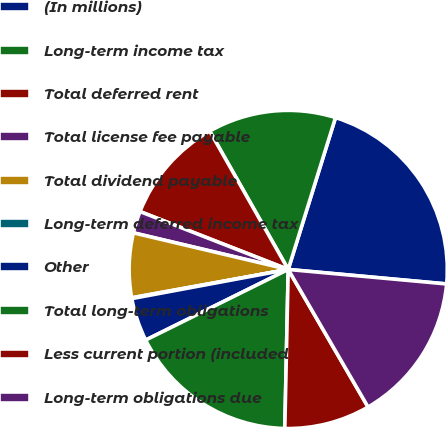Convert chart. <chart><loc_0><loc_0><loc_500><loc_500><pie_chart><fcel>(In millions)<fcel>Long-term income tax<fcel>Total deferred rent<fcel>Total license fee payable<fcel>Total dividend payable<fcel>Long-term deferred income tax<fcel>Other<fcel>Total long-term obligations<fcel>Less current portion (included<fcel>Long-term obligations due<nl><fcel>21.65%<fcel>13.02%<fcel>10.86%<fcel>2.23%<fcel>6.55%<fcel>0.08%<fcel>4.39%<fcel>17.34%<fcel>8.71%<fcel>15.18%<nl></chart> 